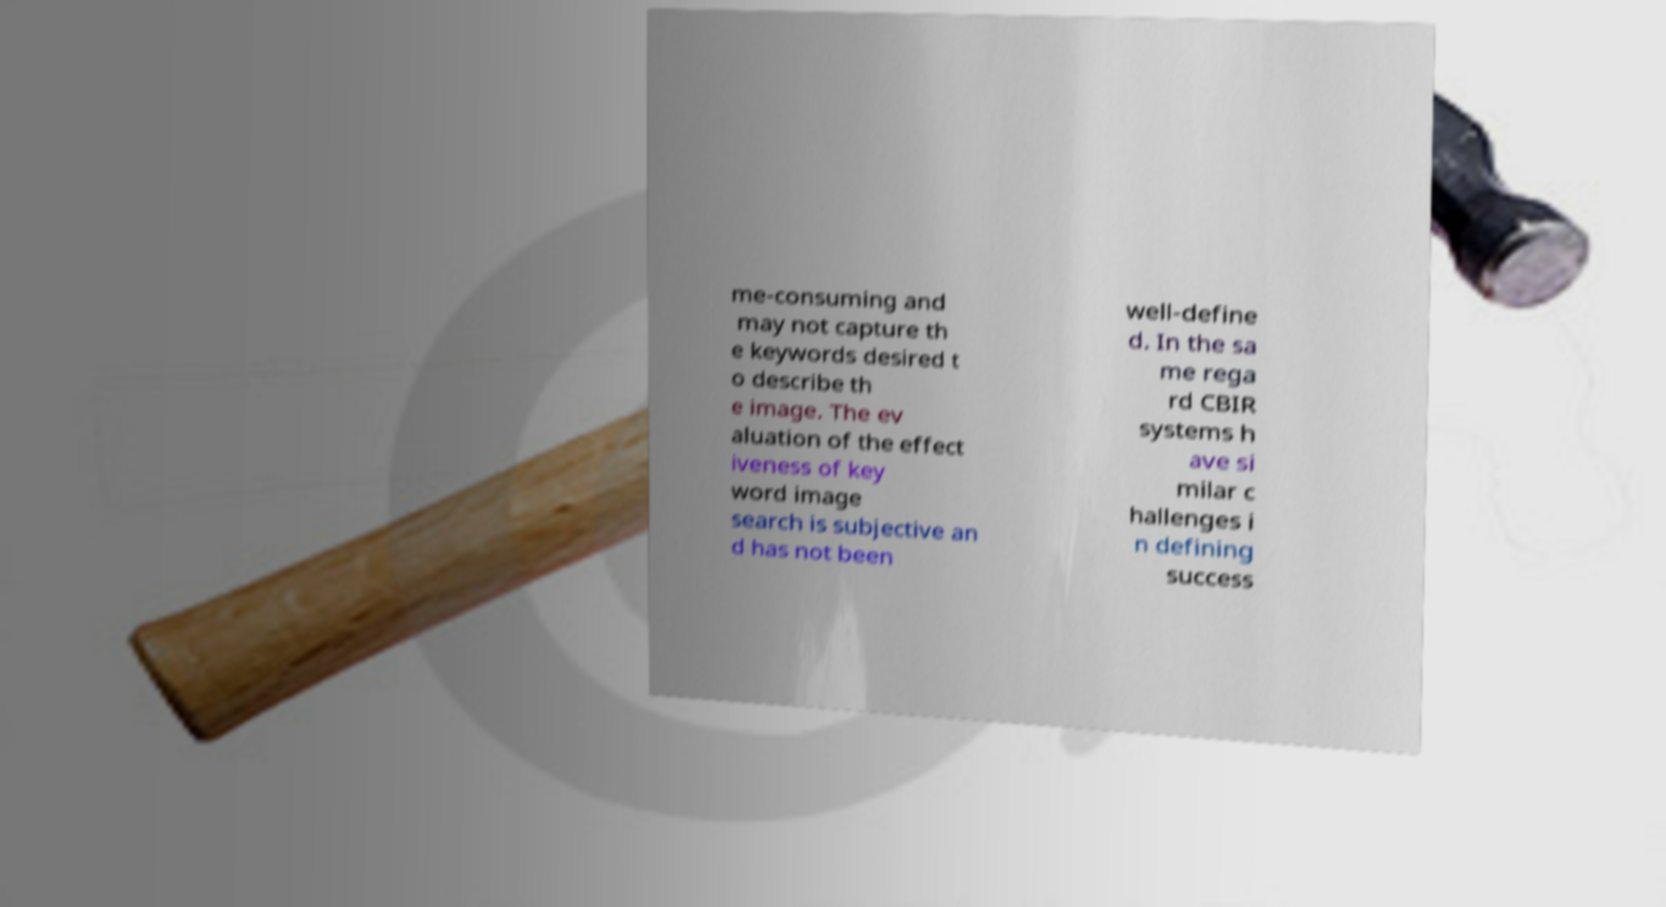I need the written content from this picture converted into text. Can you do that? me-consuming and may not capture th e keywords desired t o describe th e image. The ev aluation of the effect iveness of key word image search is subjective an d has not been well-define d. In the sa me rega rd CBIR systems h ave si milar c hallenges i n defining success 